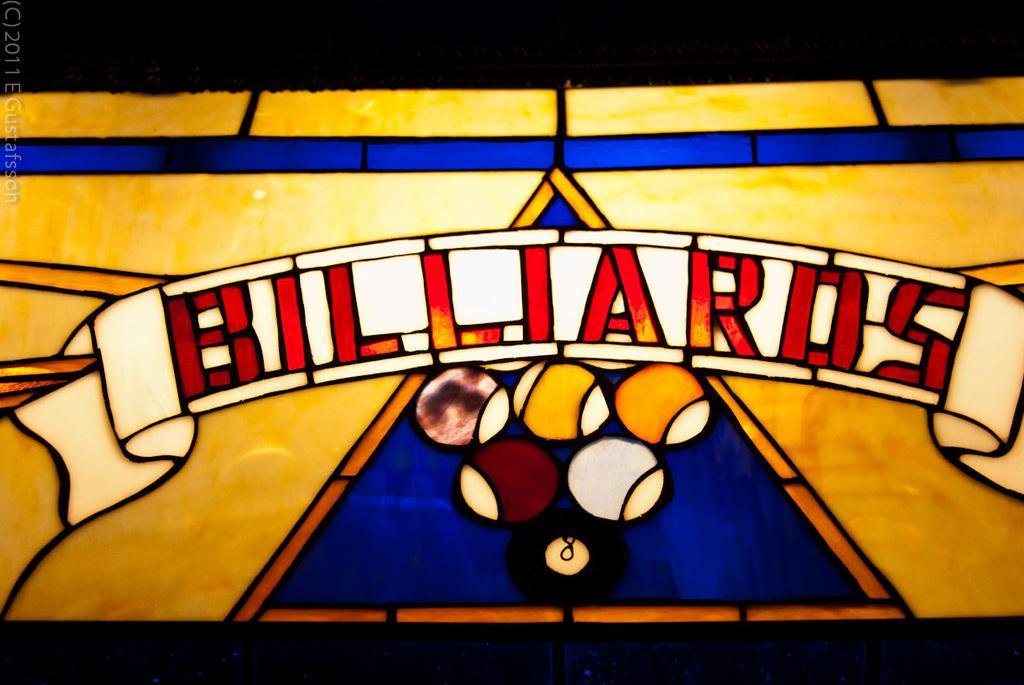Can you describe this image briefly? In this image I can see the stained glass. I can see few balls and something is written on it and it is colorful. 